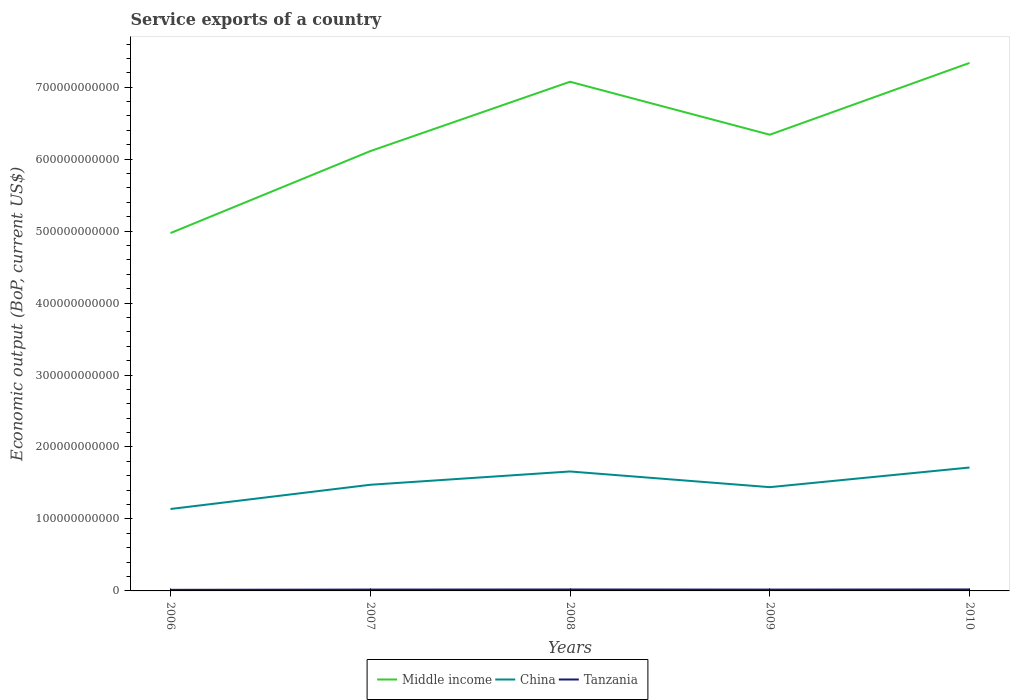Does the line corresponding to Tanzania intersect with the line corresponding to China?
Provide a succinct answer. No. Is the number of lines equal to the number of legend labels?
Provide a short and direct response. Yes. Across all years, what is the maximum service exports in Middle income?
Your answer should be compact. 4.97e+11. What is the total service exports in Tanzania in the graph?
Your answer should be very brief. -4.70e+07. What is the difference between the highest and the second highest service exports in China?
Your response must be concise. 5.76e+1. What is the difference between the highest and the lowest service exports in Tanzania?
Provide a succinct answer. 3. How many lines are there?
Offer a very short reply. 3. What is the difference between two consecutive major ticks on the Y-axis?
Provide a short and direct response. 1.00e+11. Are the values on the major ticks of Y-axis written in scientific E-notation?
Ensure brevity in your answer.  No. Does the graph contain grids?
Your answer should be compact. No. How are the legend labels stacked?
Make the answer very short. Horizontal. What is the title of the graph?
Provide a short and direct response. Service exports of a country. What is the label or title of the X-axis?
Offer a terse response. Years. What is the label or title of the Y-axis?
Your answer should be compact. Economic output (BoP, current US$). What is the Economic output (BoP, current US$) of Middle income in 2006?
Provide a succinct answer. 4.97e+11. What is the Economic output (BoP, current US$) of China in 2006?
Your answer should be compact. 1.14e+11. What is the Economic output (BoP, current US$) of Tanzania in 2006?
Your answer should be compact. 1.53e+09. What is the Economic output (BoP, current US$) in Middle income in 2007?
Your answer should be compact. 6.11e+11. What is the Economic output (BoP, current US$) of China in 2007?
Make the answer very short. 1.48e+11. What is the Economic output (BoP, current US$) of Tanzania in 2007?
Provide a short and direct response. 1.88e+09. What is the Economic output (BoP, current US$) in Middle income in 2008?
Offer a very short reply. 7.08e+11. What is the Economic output (BoP, current US$) of China in 2008?
Offer a very short reply. 1.66e+11. What is the Economic output (BoP, current US$) of Tanzania in 2008?
Offer a very short reply. 2.00e+09. What is the Economic output (BoP, current US$) of Middle income in 2009?
Make the answer very short. 6.34e+11. What is the Economic output (BoP, current US$) in China in 2009?
Keep it short and to the point. 1.44e+11. What is the Economic output (BoP, current US$) of Tanzania in 2009?
Your response must be concise. 1.85e+09. What is the Economic output (BoP, current US$) of Middle income in 2010?
Keep it short and to the point. 7.34e+11. What is the Economic output (BoP, current US$) in China in 2010?
Ensure brevity in your answer.  1.71e+11. What is the Economic output (BoP, current US$) in Tanzania in 2010?
Provide a short and direct response. 2.05e+09. Across all years, what is the maximum Economic output (BoP, current US$) of Middle income?
Keep it short and to the point. 7.34e+11. Across all years, what is the maximum Economic output (BoP, current US$) in China?
Your answer should be compact. 1.71e+11. Across all years, what is the maximum Economic output (BoP, current US$) of Tanzania?
Keep it short and to the point. 2.05e+09. Across all years, what is the minimum Economic output (BoP, current US$) of Middle income?
Ensure brevity in your answer.  4.97e+11. Across all years, what is the minimum Economic output (BoP, current US$) in China?
Your answer should be compact. 1.14e+11. Across all years, what is the minimum Economic output (BoP, current US$) of Tanzania?
Give a very brief answer. 1.53e+09. What is the total Economic output (BoP, current US$) in Middle income in the graph?
Provide a succinct answer. 3.18e+12. What is the total Economic output (BoP, current US$) in China in the graph?
Make the answer very short. 7.43e+11. What is the total Economic output (BoP, current US$) in Tanzania in the graph?
Ensure brevity in your answer.  9.30e+09. What is the difference between the Economic output (BoP, current US$) of Middle income in 2006 and that in 2007?
Provide a succinct answer. -1.14e+11. What is the difference between the Economic output (BoP, current US$) of China in 2006 and that in 2007?
Ensure brevity in your answer.  -3.37e+1. What is the difference between the Economic output (BoP, current US$) of Tanzania in 2006 and that in 2007?
Provide a short and direct response. -3.48e+08. What is the difference between the Economic output (BoP, current US$) of Middle income in 2006 and that in 2008?
Keep it short and to the point. -2.10e+11. What is the difference between the Economic output (BoP, current US$) in China in 2006 and that in 2008?
Your response must be concise. -5.21e+1. What is the difference between the Economic output (BoP, current US$) of Tanzania in 2006 and that in 2008?
Provide a short and direct response. -4.71e+08. What is the difference between the Economic output (BoP, current US$) in Middle income in 2006 and that in 2009?
Keep it short and to the point. -1.37e+11. What is the difference between the Economic output (BoP, current US$) of China in 2006 and that in 2009?
Make the answer very short. -3.03e+1. What is the difference between the Economic output (BoP, current US$) in Tanzania in 2006 and that in 2009?
Offer a very short reply. -3.27e+08. What is the difference between the Economic output (BoP, current US$) of Middle income in 2006 and that in 2010?
Make the answer very short. -2.36e+11. What is the difference between the Economic output (BoP, current US$) of China in 2006 and that in 2010?
Your answer should be very brief. -5.76e+1. What is the difference between the Economic output (BoP, current US$) of Tanzania in 2006 and that in 2010?
Your response must be concise. -5.18e+08. What is the difference between the Economic output (BoP, current US$) of Middle income in 2007 and that in 2008?
Provide a succinct answer. -9.64e+1. What is the difference between the Economic output (BoP, current US$) of China in 2007 and that in 2008?
Give a very brief answer. -1.85e+1. What is the difference between the Economic output (BoP, current US$) of Tanzania in 2007 and that in 2008?
Make the answer very short. -1.23e+08. What is the difference between the Economic output (BoP, current US$) in Middle income in 2007 and that in 2009?
Offer a terse response. -2.28e+1. What is the difference between the Economic output (BoP, current US$) in China in 2007 and that in 2009?
Make the answer very short. 3.33e+09. What is the difference between the Economic output (BoP, current US$) of Tanzania in 2007 and that in 2009?
Make the answer very short. 2.11e+07. What is the difference between the Economic output (BoP, current US$) of Middle income in 2007 and that in 2010?
Your answer should be very brief. -1.23e+11. What is the difference between the Economic output (BoP, current US$) of China in 2007 and that in 2010?
Offer a very short reply. -2.40e+1. What is the difference between the Economic output (BoP, current US$) of Tanzania in 2007 and that in 2010?
Provide a short and direct response. -1.70e+08. What is the difference between the Economic output (BoP, current US$) of Middle income in 2008 and that in 2009?
Your answer should be very brief. 7.36e+1. What is the difference between the Economic output (BoP, current US$) in China in 2008 and that in 2009?
Provide a succinct answer. 2.18e+1. What is the difference between the Economic output (BoP, current US$) of Tanzania in 2008 and that in 2009?
Your response must be concise. 1.44e+08. What is the difference between the Economic output (BoP, current US$) in Middle income in 2008 and that in 2010?
Give a very brief answer. -2.62e+1. What is the difference between the Economic output (BoP, current US$) in China in 2008 and that in 2010?
Your answer should be very brief. -5.50e+09. What is the difference between the Economic output (BoP, current US$) in Tanzania in 2008 and that in 2010?
Your answer should be compact. -4.70e+07. What is the difference between the Economic output (BoP, current US$) of Middle income in 2009 and that in 2010?
Your answer should be compact. -9.98e+1. What is the difference between the Economic output (BoP, current US$) of China in 2009 and that in 2010?
Your response must be concise. -2.73e+1. What is the difference between the Economic output (BoP, current US$) of Tanzania in 2009 and that in 2010?
Your answer should be very brief. -1.91e+08. What is the difference between the Economic output (BoP, current US$) in Middle income in 2006 and the Economic output (BoP, current US$) in China in 2007?
Keep it short and to the point. 3.50e+11. What is the difference between the Economic output (BoP, current US$) of Middle income in 2006 and the Economic output (BoP, current US$) of Tanzania in 2007?
Provide a succinct answer. 4.95e+11. What is the difference between the Economic output (BoP, current US$) in China in 2006 and the Economic output (BoP, current US$) in Tanzania in 2007?
Give a very brief answer. 1.12e+11. What is the difference between the Economic output (BoP, current US$) of Middle income in 2006 and the Economic output (BoP, current US$) of China in 2008?
Your answer should be very brief. 3.31e+11. What is the difference between the Economic output (BoP, current US$) of Middle income in 2006 and the Economic output (BoP, current US$) of Tanzania in 2008?
Offer a very short reply. 4.95e+11. What is the difference between the Economic output (BoP, current US$) in China in 2006 and the Economic output (BoP, current US$) in Tanzania in 2008?
Your answer should be compact. 1.12e+11. What is the difference between the Economic output (BoP, current US$) in Middle income in 2006 and the Economic output (BoP, current US$) in China in 2009?
Your response must be concise. 3.53e+11. What is the difference between the Economic output (BoP, current US$) of Middle income in 2006 and the Economic output (BoP, current US$) of Tanzania in 2009?
Your answer should be compact. 4.95e+11. What is the difference between the Economic output (BoP, current US$) of China in 2006 and the Economic output (BoP, current US$) of Tanzania in 2009?
Offer a very short reply. 1.12e+11. What is the difference between the Economic output (BoP, current US$) of Middle income in 2006 and the Economic output (BoP, current US$) of China in 2010?
Provide a short and direct response. 3.26e+11. What is the difference between the Economic output (BoP, current US$) of Middle income in 2006 and the Economic output (BoP, current US$) of Tanzania in 2010?
Your answer should be compact. 4.95e+11. What is the difference between the Economic output (BoP, current US$) of China in 2006 and the Economic output (BoP, current US$) of Tanzania in 2010?
Your response must be concise. 1.12e+11. What is the difference between the Economic output (BoP, current US$) in Middle income in 2007 and the Economic output (BoP, current US$) in China in 2008?
Ensure brevity in your answer.  4.45e+11. What is the difference between the Economic output (BoP, current US$) of Middle income in 2007 and the Economic output (BoP, current US$) of Tanzania in 2008?
Keep it short and to the point. 6.09e+11. What is the difference between the Economic output (BoP, current US$) of China in 2007 and the Economic output (BoP, current US$) of Tanzania in 2008?
Provide a succinct answer. 1.46e+11. What is the difference between the Economic output (BoP, current US$) of Middle income in 2007 and the Economic output (BoP, current US$) of China in 2009?
Provide a succinct answer. 4.67e+11. What is the difference between the Economic output (BoP, current US$) of Middle income in 2007 and the Economic output (BoP, current US$) of Tanzania in 2009?
Make the answer very short. 6.09e+11. What is the difference between the Economic output (BoP, current US$) in China in 2007 and the Economic output (BoP, current US$) in Tanzania in 2009?
Ensure brevity in your answer.  1.46e+11. What is the difference between the Economic output (BoP, current US$) of Middle income in 2007 and the Economic output (BoP, current US$) of China in 2010?
Your response must be concise. 4.40e+11. What is the difference between the Economic output (BoP, current US$) of Middle income in 2007 and the Economic output (BoP, current US$) of Tanzania in 2010?
Provide a short and direct response. 6.09e+11. What is the difference between the Economic output (BoP, current US$) of China in 2007 and the Economic output (BoP, current US$) of Tanzania in 2010?
Provide a short and direct response. 1.45e+11. What is the difference between the Economic output (BoP, current US$) of Middle income in 2008 and the Economic output (BoP, current US$) of China in 2009?
Keep it short and to the point. 5.63e+11. What is the difference between the Economic output (BoP, current US$) in Middle income in 2008 and the Economic output (BoP, current US$) in Tanzania in 2009?
Your response must be concise. 7.06e+11. What is the difference between the Economic output (BoP, current US$) of China in 2008 and the Economic output (BoP, current US$) of Tanzania in 2009?
Make the answer very short. 1.64e+11. What is the difference between the Economic output (BoP, current US$) in Middle income in 2008 and the Economic output (BoP, current US$) in China in 2010?
Offer a very short reply. 5.36e+11. What is the difference between the Economic output (BoP, current US$) of Middle income in 2008 and the Economic output (BoP, current US$) of Tanzania in 2010?
Provide a succinct answer. 7.06e+11. What is the difference between the Economic output (BoP, current US$) in China in 2008 and the Economic output (BoP, current US$) in Tanzania in 2010?
Offer a terse response. 1.64e+11. What is the difference between the Economic output (BoP, current US$) in Middle income in 2009 and the Economic output (BoP, current US$) in China in 2010?
Offer a very short reply. 4.62e+11. What is the difference between the Economic output (BoP, current US$) of Middle income in 2009 and the Economic output (BoP, current US$) of Tanzania in 2010?
Your answer should be compact. 6.32e+11. What is the difference between the Economic output (BoP, current US$) in China in 2009 and the Economic output (BoP, current US$) in Tanzania in 2010?
Your answer should be very brief. 1.42e+11. What is the average Economic output (BoP, current US$) in Middle income per year?
Offer a very short reply. 6.37e+11. What is the average Economic output (BoP, current US$) of China per year?
Keep it short and to the point. 1.49e+11. What is the average Economic output (BoP, current US$) in Tanzania per year?
Make the answer very short. 1.86e+09. In the year 2006, what is the difference between the Economic output (BoP, current US$) in Middle income and Economic output (BoP, current US$) in China?
Provide a short and direct response. 3.83e+11. In the year 2006, what is the difference between the Economic output (BoP, current US$) of Middle income and Economic output (BoP, current US$) of Tanzania?
Offer a very short reply. 4.96e+11. In the year 2006, what is the difference between the Economic output (BoP, current US$) of China and Economic output (BoP, current US$) of Tanzania?
Provide a short and direct response. 1.12e+11. In the year 2007, what is the difference between the Economic output (BoP, current US$) of Middle income and Economic output (BoP, current US$) of China?
Your answer should be compact. 4.64e+11. In the year 2007, what is the difference between the Economic output (BoP, current US$) of Middle income and Economic output (BoP, current US$) of Tanzania?
Your answer should be very brief. 6.09e+11. In the year 2007, what is the difference between the Economic output (BoP, current US$) in China and Economic output (BoP, current US$) in Tanzania?
Give a very brief answer. 1.46e+11. In the year 2008, what is the difference between the Economic output (BoP, current US$) of Middle income and Economic output (BoP, current US$) of China?
Offer a very short reply. 5.42e+11. In the year 2008, what is the difference between the Economic output (BoP, current US$) of Middle income and Economic output (BoP, current US$) of Tanzania?
Offer a terse response. 7.06e+11. In the year 2008, what is the difference between the Economic output (BoP, current US$) of China and Economic output (BoP, current US$) of Tanzania?
Give a very brief answer. 1.64e+11. In the year 2009, what is the difference between the Economic output (BoP, current US$) in Middle income and Economic output (BoP, current US$) in China?
Provide a short and direct response. 4.90e+11. In the year 2009, what is the difference between the Economic output (BoP, current US$) in Middle income and Economic output (BoP, current US$) in Tanzania?
Offer a very short reply. 6.32e+11. In the year 2009, what is the difference between the Economic output (BoP, current US$) in China and Economic output (BoP, current US$) in Tanzania?
Your answer should be very brief. 1.42e+11. In the year 2010, what is the difference between the Economic output (BoP, current US$) in Middle income and Economic output (BoP, current US$) in China?
Offer a very short reply. 5.62e+11. In the year 2010, what is the difference between the Economic output (BoP, current US$) in Middle income and Economic output (BoP, current US$) in Tanzania?
Ensure brevity in your answer.  7.32e+11. In the year 2010, what is the difference between the Economic output (BoP, current US$) of China and Economic output (BoP, current US$) of Tanzania?
Ensure brevity in your answer.  1.69e+11. What is the ratio of the Economic output (BoP, current US$) in Middle income in 2006 to that in 2007?
Give a very brief answer. 0.81. What is the ratio of the Economic output (BoP, current US$) of China in 2006 to that in 2007?
Offer a terse response. 0.77. What is the ratio of the Economic output (BoP, current US$) of Tanzania in 2006 to that in 2007?
Offer a terse response. 0.81. What is the ratio of the Economic output (BoP, current US$) of Middle income in 2006 to that in 2008?
Offer a terse response. 0.7. What is the ratio of the Economic output (BoP, current US$) in China in 2006 to that in 2008?
Provide a short and direct response. 0.69. What is the ratio of the Economic output (BoP, current US$) in Tanzania in 2006 to that in 2008?
Your answer should be compact. 0.76. What is the ratio of the Economic output (BoP, current US$) in Middle income in 2006 to that in 2009?
Provide a succinct answer. 0.78. What is the ratio of the Economic output (BoP, current US$) of China in 2006 to that in 2009?
Offer a very short reply. 0.79. What is the ratio of the Economic output (BoP, current US$) of Tanzania in 2006 to that in 2009?
Your answer should be very brief. 0.82. What is the ratio of the Economic output (BoP, current US$) in Middle income in 2006 to that in 2010?
Your answer should be very brief. 0.68. What is the ratio of the Economic output (BoP, current US$) of China in 2006 to that in 2010?
Give a very brief answer. 0.66. What is the ratio of the Economic output (BoP, current US$) of Tanzania in 2006 to that in 2010?
Provide a short and direct response. 0.75. What is the ratio of the Economic output (BoP, current US$) in Middle income in 2007 to that in 2008?
Ensure brevity in your answer.  0.86. What is the ratio of the Economic output (BoP, current US$) in China in 2007 to that in 2008?
Your response must be concise. 0.89. What is the ratio of the Economic output (BoP, current US$) in Tanzania in 2007 to that in 2008?
Your answer should be very brief. 0.94. What is the ratio of the Economic output (BoP, current US$) of China in 2007 to that in 2009?
Your answer should be very brief. 1.02. What is the ratio of the Economic output (BoP, current US$) in Tanzania in 2007 to that in 2009?
Offer a terse response. 1.01. What is the ratio of the Economic output (BoP, current US$) in Middle income in 2007 to that in 2010?
Give a very brief answer. 0.83. What is the ratio of the Economic output (BoP, current US$) of China in 2007 to that in 2010?
Keep it short and to the point. 0.86. What is the ratio of the Economic output (BoP, current US$) of Tanzania in 2007 to that in 2010?
Provide a short and direct response. 0.92. What is the ratio of the Economic output (BoP, current US$) of Middle income in 2008 to that in 2009?
Offer a very short reply. 1.12. What is the ratio of the Economic output (BoP, current US$) in China in 2008 to that in 2009?
Give a very brief answer. 1.15. What is the ratio of the Economic output (BoP, current US$) of Tanzania in 2008 to that in 2009?
Provide a short and direct response. 1.08. What is the ratio of the Economic output (BoP, current US$) of China in 2008 to that in 2010?
Keep it short and to the point. 0.97. What is the ratio of the Economic output (BoP, current US$) in Tanzania in 2008 to that in 2010?
Offer a terse response. 0.98. What is the ratio of the Economic output (BoP, current US$) in Middle income in 2009 to that in 2010?
Ensure brevity in your answer.  0.86. What is the ratio of the Economic output (BoP, current US$) in China in 2009 to that in 2010?
Give a very brief answer. 0.84. What is the ratio of the Economic output (BoP, current US$) in Tanzania in 2009 to that in 2010?
Give a very brief answer. 0.91. What is the difference between the highest and the second highest Economic output (BoP, current US$) in Middle income?
Give a very brief answer. 2.62e+1. What is the difference between the highest and the second highest Economic output (BoP, current US$) of China?
Offer a terse response. 5.50e+09. What is the difference between the highest and the second highest Economic output (BoP, current US$) of Tanzania?
Keep it short and to the point. 4.70e+07. What is the difference between the highest and the lowest Economic output (BoP, current US$) of Middle income?
Provide a succinct answer. 2.36e+11. What is the difference between the highest and the lowest Economic output (BoP, current US$) of China?
Provide a short and direct response. 5.76e+1. What is the difference between the highest and the lowest Economic output (BoP, current US$) of Tanzania?
Your answer should be compact. 5.18e+08. 